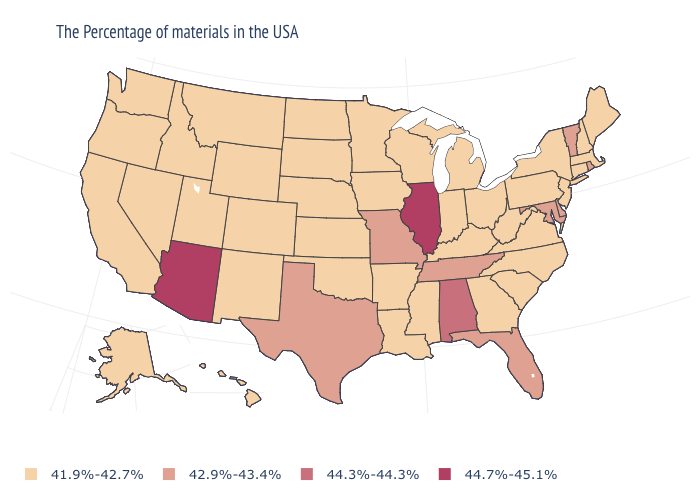Is the legend a continuous bar?
Quick response, please. No. What is the value of Montana?
Concise answer only. 41.9%-42.7%. Which states have the highest value in the USA?
Concise answer only. Illinois, Arizona. Does Hawaii have the same value as New Jersey?
Concise answer only. Yes. Which states have the highest value in the USA?
Write a very short answer. Illinois, Arizona. How many symbols are there in the legend?
Quick response, please. 4. Does Rhode Island have a lower value than Kentucky?
Quick response, please. No. What is the value of Oregon?
Give a very brief answer. 41.9%-42.7%. Among the states that border Missouri , does Kentucky have the highest value?
Give a very brief answer. No. Does Hawaii have a higher value than Virginia?
Concise answer only. No. Name the states that have a value in the range 41.9%-42.7%?
Concise answer only. Maine, Massachusetts, New Hampshire, Connecticut, New York, New Jersey, Pennsylvania, Virginia, North Carolina, South Carolina, West Virginia, Ohio, Georgia, Michigan, Kentucky, Indiana, Wisconsin, Mississippi, Louisiana, Arkansas, Minnesota, Iowa, Kansas, Nebraska, Oklahoma, South Dakota, North Dakota, Wyoming, Colorado, New Mexico, Utah, Montana, Idaho, Nevada, California, Washington, Oregon, Alaska, Hawaii. Does the map have missing data?
Be succinct. No. What is the value of Washington?
Be succinct. 41.9%-42.7%. Which states have the highest value in the USA?
Be succinct. Illinois, Arizona. 